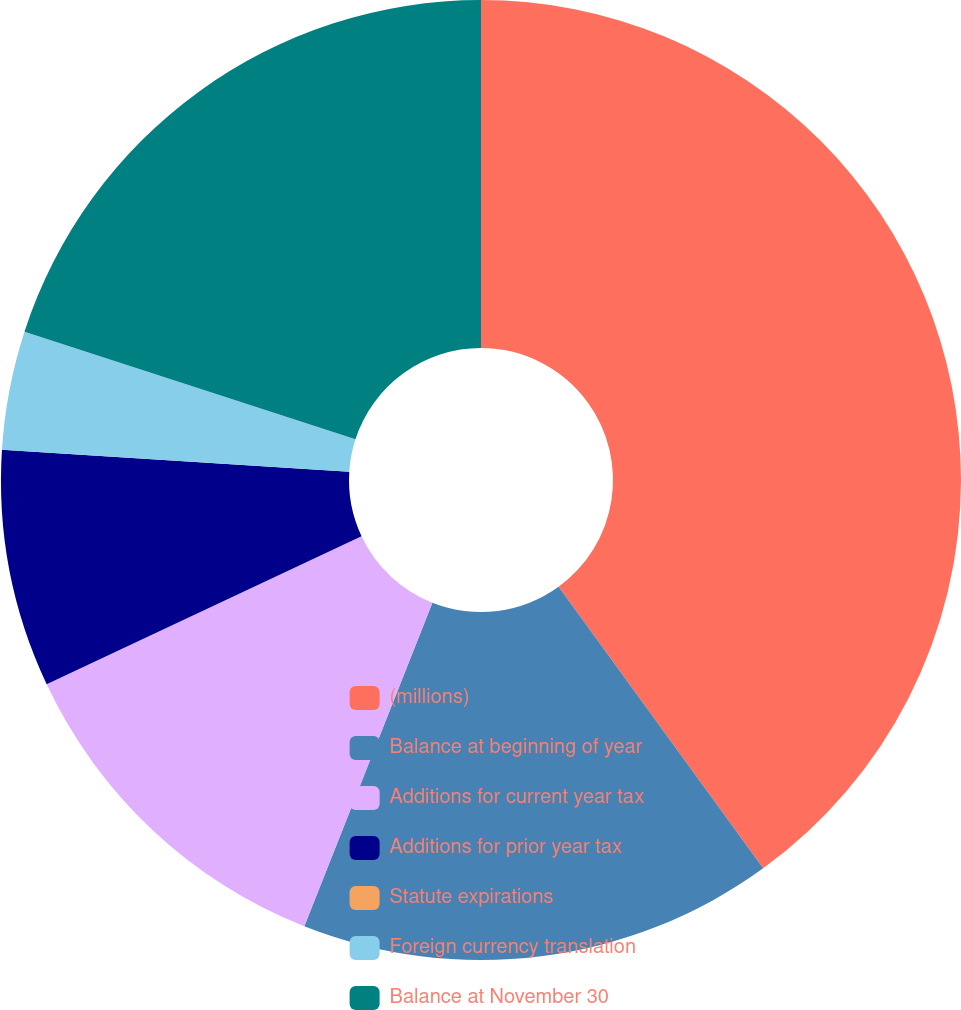Convert chart to OTSL. <chart><loc_0><loc_0><loc_500><loc_500><pie_chart><fcel>(millions)<fcel>Balance at beginning of year<fcel>Additions for current year tax<fcel>Additions for prior year tax<fcel>Statute expirations<fcel>Foreign currency translation<fcel>Balance at November 30<nl><fcel>40.0%<fcel>16.0%<fcel>12.0%<fcel>8.0%<fcel>0.0%<fcel>4.0%<fcel>20.0%<nl></chart> 